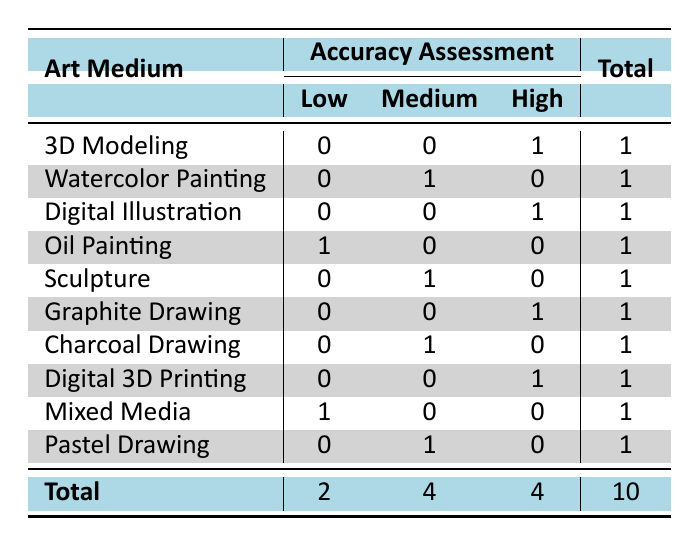What is the total number of researchers that assessed their anatomical accuracy as 'High'? In the table, we look for the rows with 'High' in the accuracy assessment column. There are 4 rows (3D Modeling, Digital Illustration, Graphite Drawing, Digital 3D Printing) marked as 'High'. Therefore, the count is 4.
Answer: 4 How many art mediums are associated with a 'Low' accuracy assessment? By examining the table, we notice that there are 2 mediums associated with 'Low' accuracy (Oil Painting and Mixed Media). Thus, the total is 2.
Answer: 2 Is there any medium that has not been assessed as 'Medium'? Reviewing the table, we see that '3D Modeling', 'Digital Illustration', 'Graphite Drawing', and 'Digital 3D Printing' do not have any 'Medium' assessments. Therefore, it is true that there are mediums without any 'Medium' assessment.
Answer: Yes What is the difference between the number of mediums with 'Medium' and 'High' accuracy assessments? From the table, the number of mediums with 'Medium' accuracy is 4, and those with 'High' is also 4. Therefore, the difference is 4 - 4 = 0.
Answer: 0 Which art medium has both 'Medium' and 'Low' assessments? Looking at the table, we can see that 'Charcoal Drawing' only has a 'Medium' assessment, while 'Oil Painting' and 'Mixed Media' have a 'Low' assessment. Thus, there is no medium that has both types.
Answer: None 